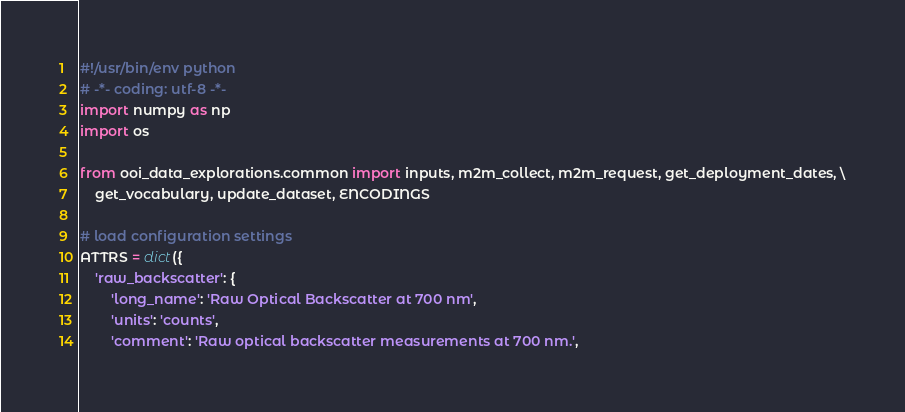<code> <loc_0><loc_0><loc_500><loc_500><_Python_>#!/usr/bin/env python
# -*- coding: utf-8 -*-
import numpy as np
import os

from ooi_data_explorations.common import inputs, m2m_collect, m2m_request, get_deployment_dates, \
    get_vocabulary, update_dataset, ENCODINGS

# load configuration settings
ATTRS = dict({
    'raw_backscatter': {
        'long_name': 'Raw Optical Backscatter at 700 nm',
        'units': 'counts',
        'comment': 'Raw optical backscatter measurements at 700 nm.',</code> 